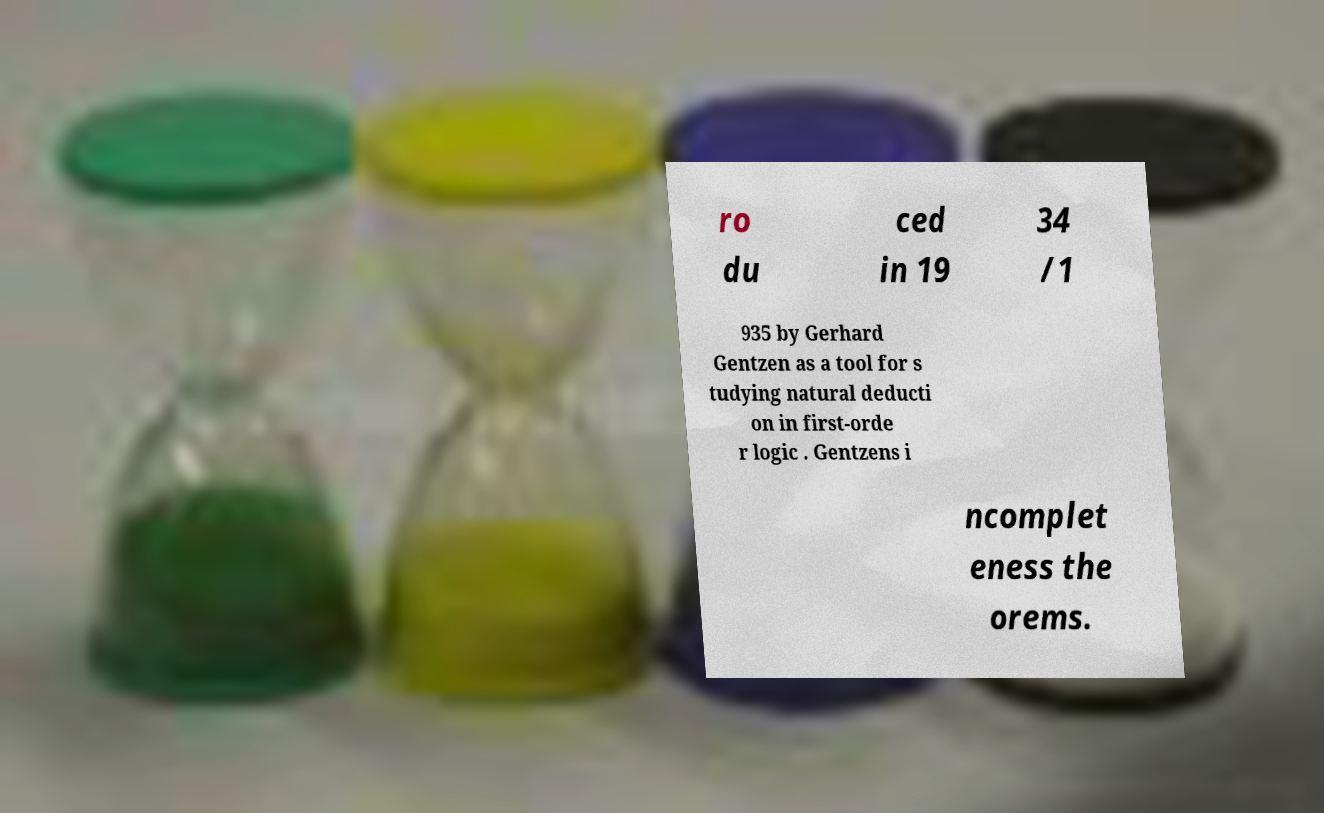Could you extract and type out the text from this image? ro du ced in 19 34 /1 935 by Gerhard Gentzen as a tool for s tudying natural deducti on in first-orde r logic . Gentzens i ncomplet eness the orems. 